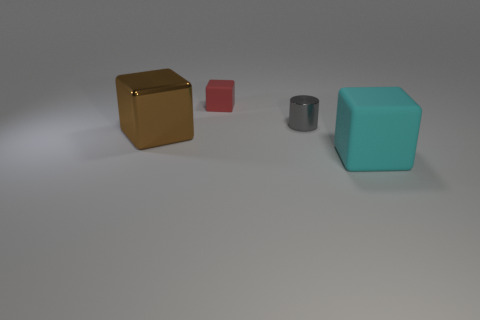Is there any other thing that has the same material as the large brown cube?
Keep it short and to the point. Yes. The brown shiny object that is the same shape as the red object is what size?
Offer a very short reply. Large. Are there any gray things left of the brown metal thing?
Your answer should be very brief. No. What is the material of the red cube?
Offer a very short reply. Rubber. There is a matte block that is on the right side of the red rubber object; is its color the same as the tiny block?
Make the answer very short. No. Is there anything else that is the same shape as the tiny red matte thing?
Your response must be concise. Yes. There is another large rubber object that is the same shape as the red thing; what color is it?
Offer a very short reply. Cyan. There is a small object on the right side of the small matte thing; what is its material?
Provide a short and direct response. Metal. What is the color of the tiny cylinder?
Provide a succinct answer. Gray. There is a metal object that is on the right side of the red matte cube; is its size the same as the big cyan matte block?
Your answer should be compact. No. 